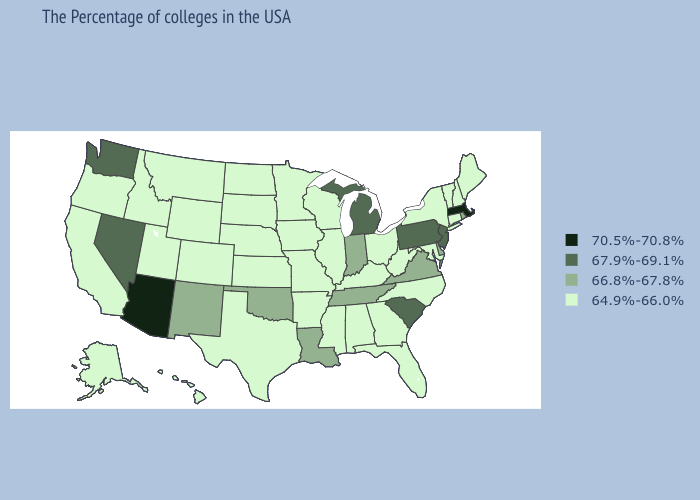What is the value of Rhode Island?
Short answer required. 66.8%-67.8%. Name the states that have a value in the range 70.5%-70.8%?
Short answer required. Massachusetts, Arizona. Name the states that have a value in the range 70.5%-70.8%?
Keep it brief. Massachusetts, Arizona. What is the lowest value in the USA?
Write a very short answer. 64.9%-66.0%. What is the value of Colorado?
Keep it brief. 64.9%-66.0%. Among the states that border New York , does Massachusetts have the lowest value?
Quick response, please. No. Does the first symbol in the legend represent the smallest category?
Be succinct. No. Name the states that have a value in the range 70.5%-70.8%?
Concise answer only. Massachusetts, Arizona. Which states have the lowest value in the USA?
Give a very brief answer. Maine, New Hampshire, Vermont, Connecticut, New York, Maryland, North Carolina, West Virginia, Ohio, Florida, Georgia, Kentucky, Alabama, Wisconsin, Illinois, Mississippi, Missouri, Arkansas, Minnesota, Iowa, Kansas, Nebraska, Texas, South Dakota, North Dakota, Wyoming, Colorado, Utah, Montana, Idaho, California, Oregon, Alaska, Hawaii. Name the states that have a value in the range 66.8%-67.8%?
Write a very short answer. Rhode Island, Delaware, Virginia, Indiana, Tennessee, Louisiana, Oklahoma, New Mexico. Name the states that have a value in the range 67.9%-69.1%?
Short answer required. New Jersey, Pennsylvania, South Carolina, Michigan, Nevada, Washington. Name the states that have a value in the range 66.8%-67.8%?
Concise answer only. Rhode Island, Delaware, Virginia, Indiana, Tennessee, Louisiana, Oklahoma, New Mexico. What is the lowest value in the MidWest?
Be succinct. 64.9%-66.0%. Does the map have missing data?
Write a very short answer. No. What is the lowest value in states that border West Virginia?
Write a very short answer. 64.9%-66.0%. 